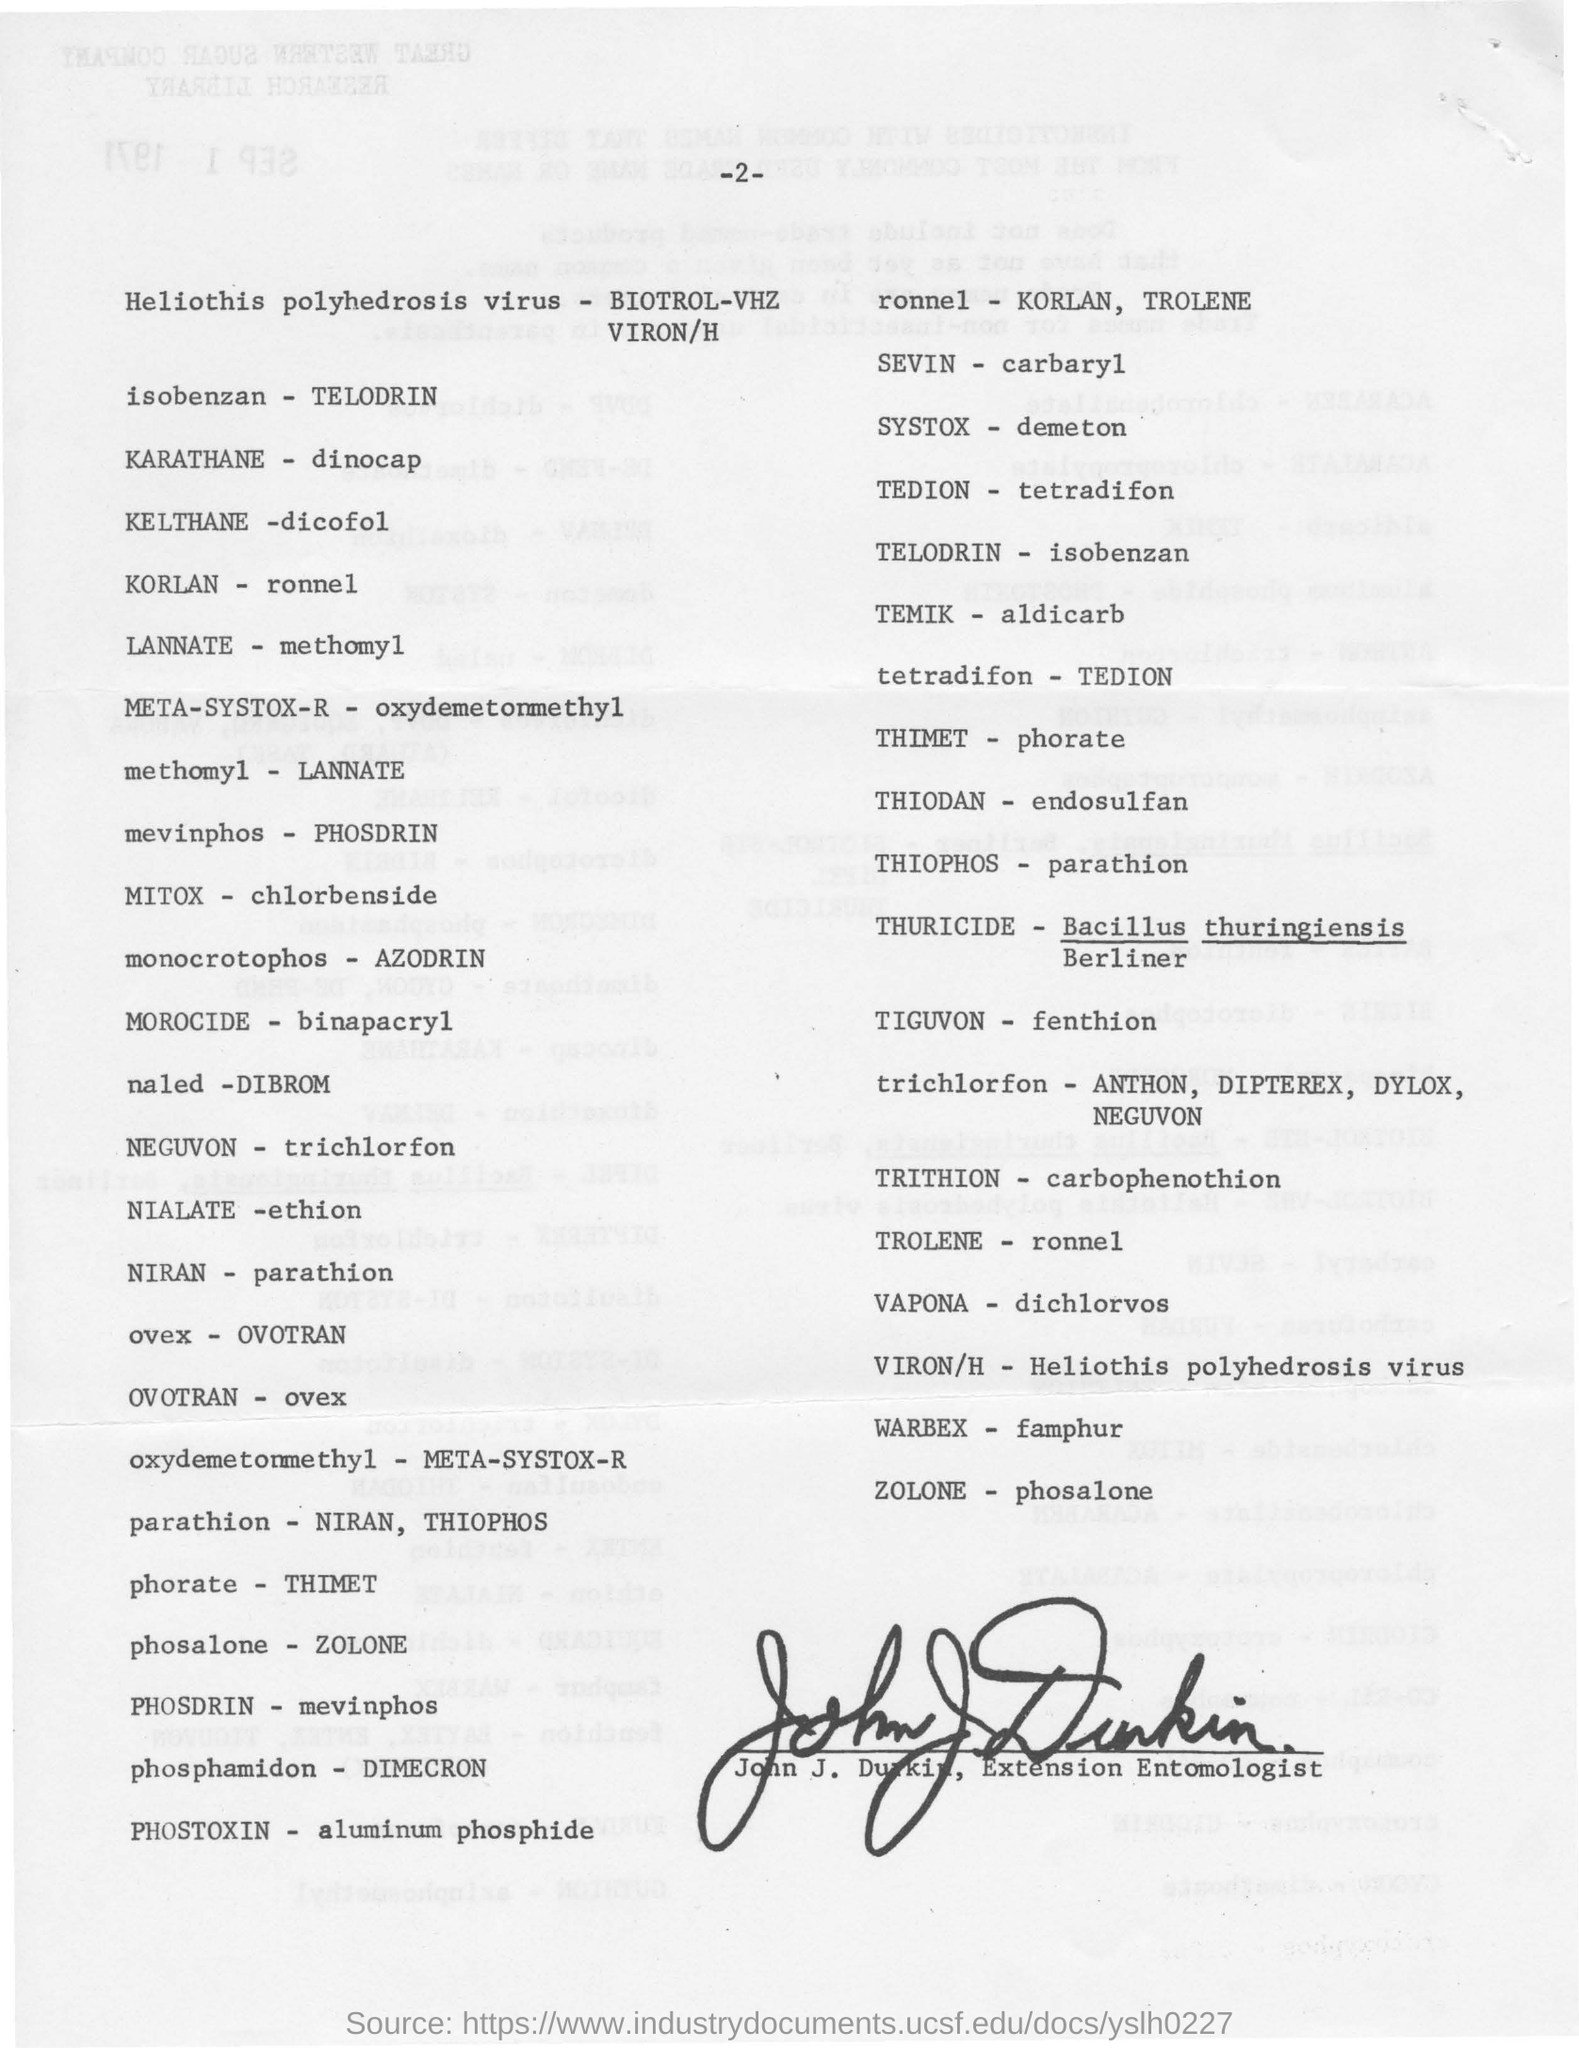Point out several critical features in this image. The word opposite to KORLAN and TROLENE is RONNEL. The word 'phosalone' is mentioned as the opposite of 'ZOLONE'. Trichlorfon is the opposite of neguvon. 